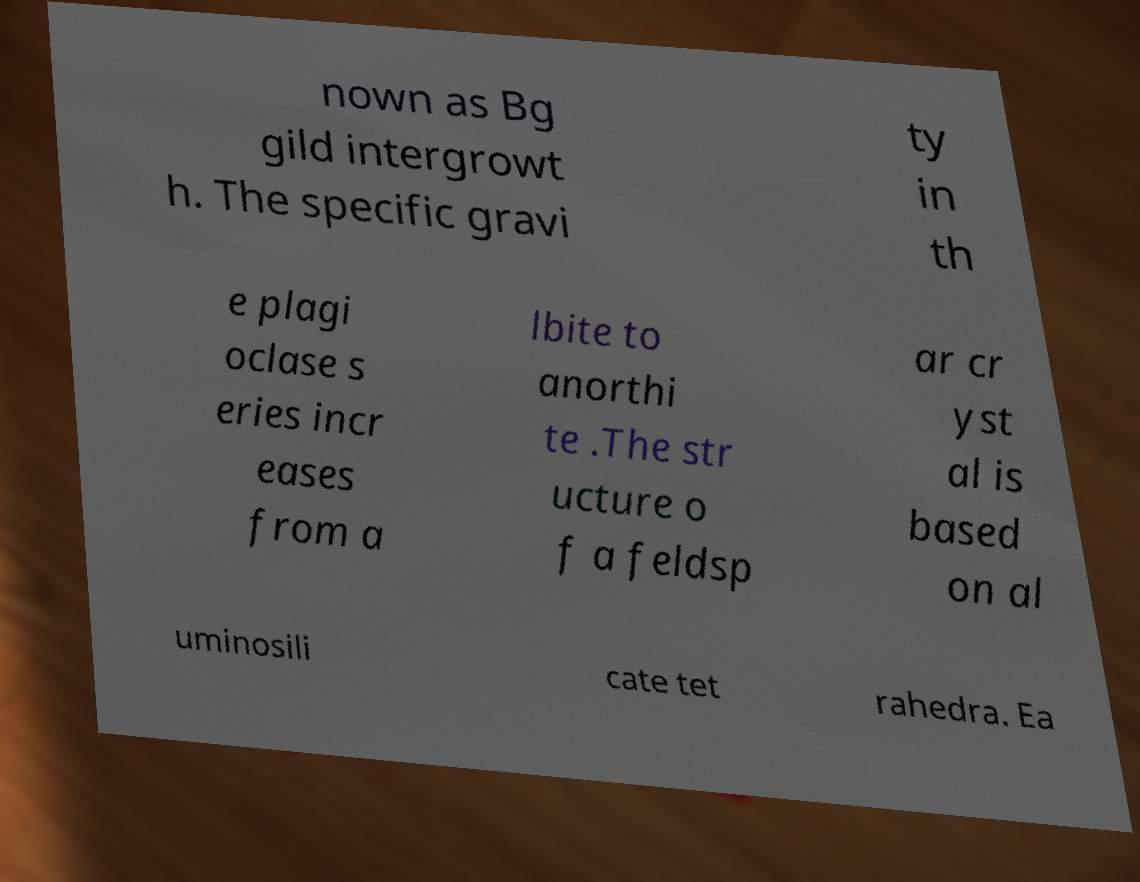There's text embedded in this image that I need extracted. Can you transcribe it verbatim? nown as Bg gild intergrowt h. The specific gravi ty in th e plagi oclase s eries incr eases from a lbite to anorthi te .The str ucture o f a feldsp ar cr yst al is based on al uminosili cate tet rahedra. Ea 